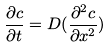<formula> <loc_0><loc_0><loc_500><loc_500>\frac { \partial c } { \partial t } = D ( \frac { \partial ^ { 2 } c } { \partial x ^ { 2 } } )</formula> 